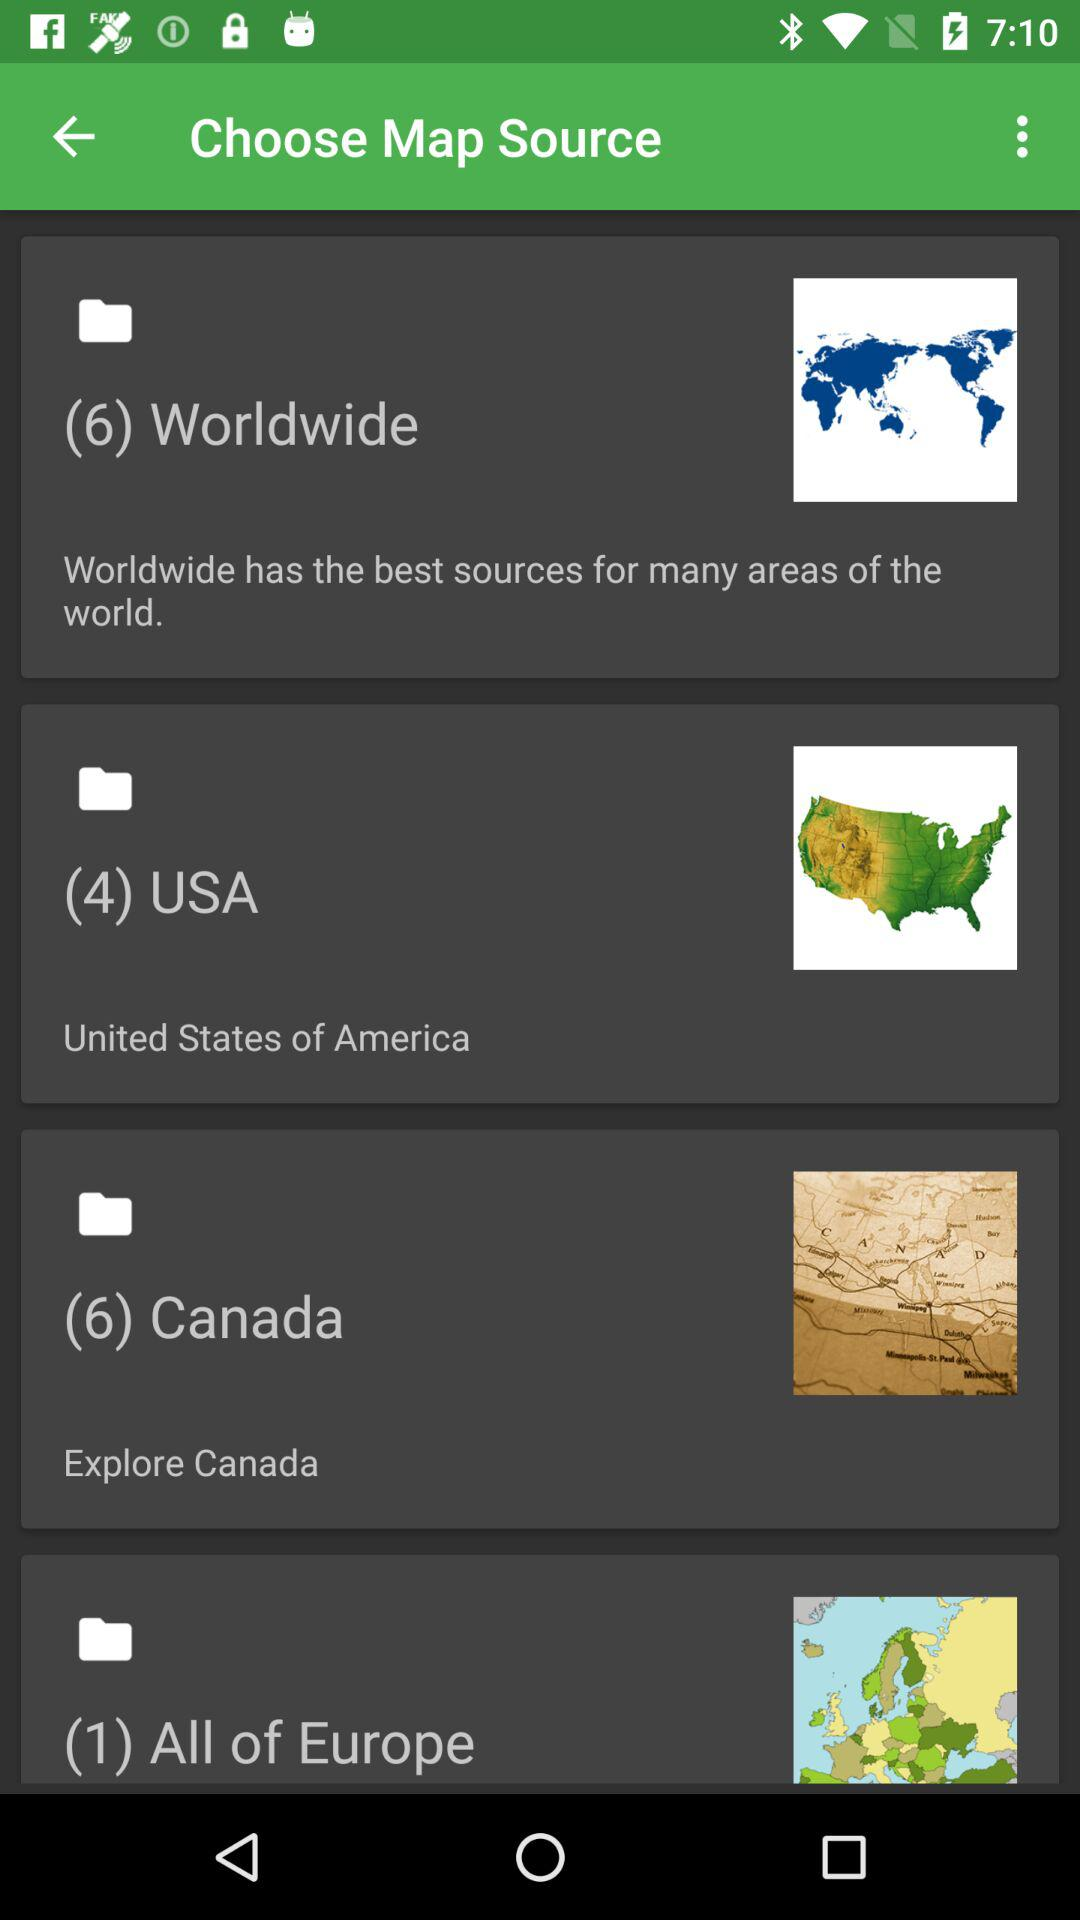What is the file count in the "Worldwide" folder? The file count in the "Worldwide" folder is 6. 